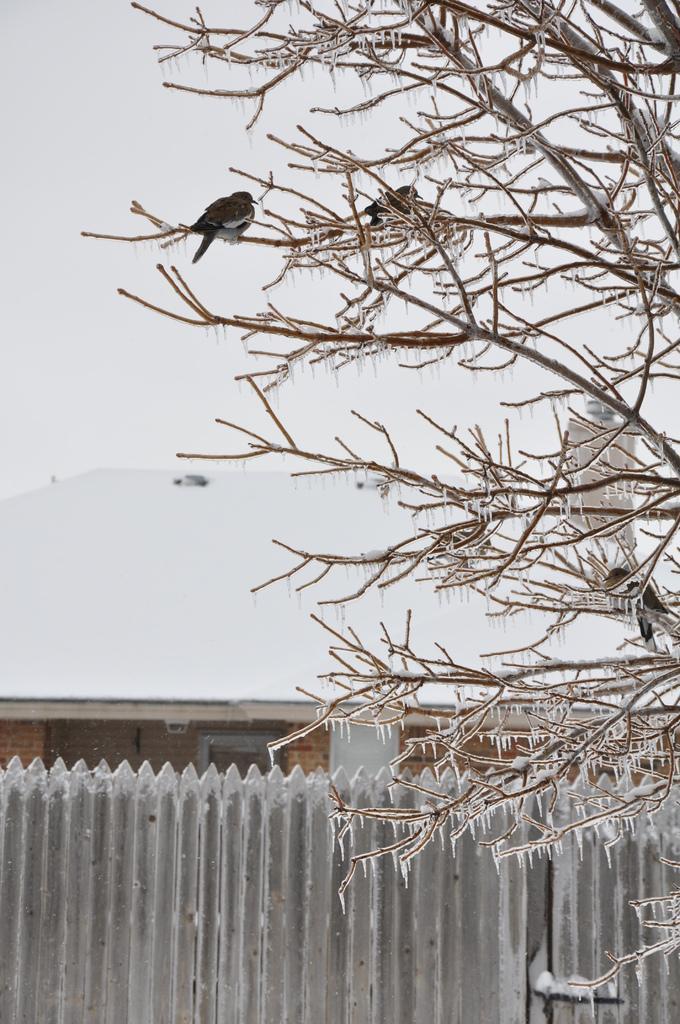How would you summarize this image in a sentence or two? In this image there are birds on a trees, in the background there is a fencing, shed. 